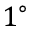Convert formula to latex. <formula><loc_0><loc_0><loc_500><loc_500>1 ^ { \circ }</formula> 